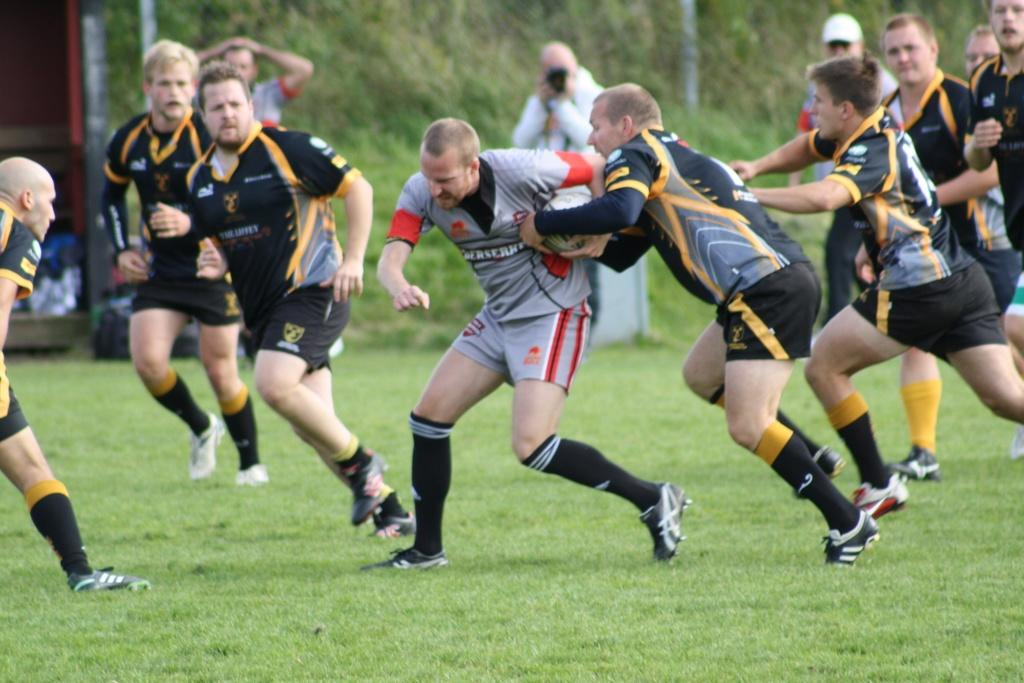What is happening in the image involving a group of people? The people in the image are running on the ground. Are there any objects being held by the people in the image? Yes, two people are holding a ball. What can be seen in the background of the image? There are trees in the background of the image. What type of letter is being passed between the two people holding the ball in the image? There is no letter present in the image; only a ball is being held by two people. 